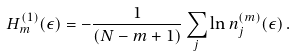Convert formula to latex. <formula><loc_0><loc_0><loc_500><loc_500>H _ { m } ^ { ( 1 ) } ( \epsilon ) = - \frac { 1 } { ( N - m + 1 ) } \sum _ { j } \ln n _ { j } ^ { ( m ) } ( \epsilon ) \, .</formula> 